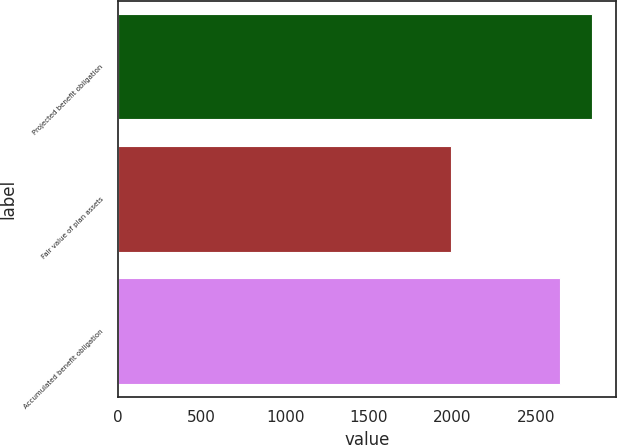<chart> <loc_0><loc_0><loc_500><loc_500><bar_chart><fcel>Projected benefit obligation<fcel>Fair value of plan assets<fcel>Accumulated benefit obligation<nl><fcel>2834<fcel>1992<fcel>2641<nl></chart> 